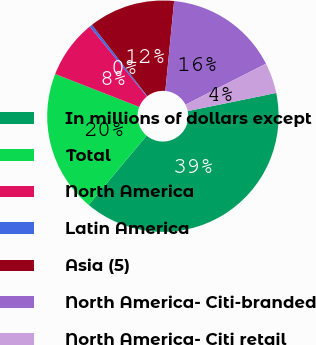<chart> <loc_0><loc_0><loc_500><loc_500><pie_chart><fcel>In millions of dollars except<fcel>Total<fcel>North America<fcel>Latin America<fcel>Asia (5)<fcel>North America- Citi-branded<fcel>North America- Citi retail<nl><fcel>39.31%<fcel>19.85%<fcel>8.17%<fcel>0.38%<fcel>12.06%<fcel>15.95%<fcel>4.28%<nl></chart> 